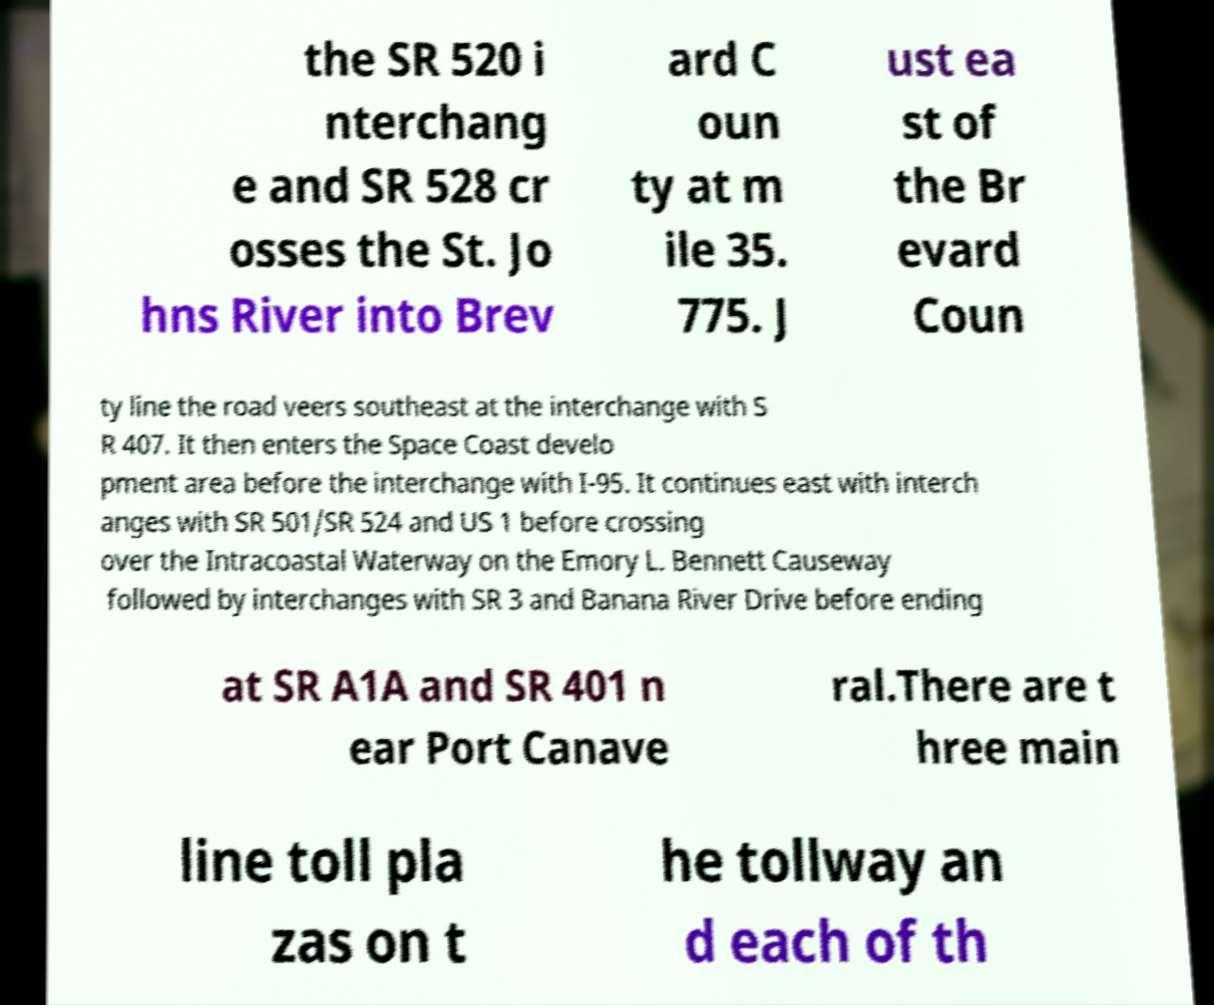Can you read and provide the text displayed in the image?This photo seems to have some interesting text. Can you extract and type it out for me? the SR 520 i nterchang e and SR 528 cr osses the St. Jo hns River into Brev ard C oun ty at m ile 35. 775. J ust ea st of the Br evard Coun ty line the road veers southeast at the interchange with S R 407. It then enters the Space Coast develo pment area before the interchange with I-95. It continues east with interch anges with SR 501/SR 524 and US 1 before crossing over the Intracoastal Waterway on the Emory L. Bennett Causeway followed by interchanges with SR 3 and Banana River Drive before ending at SR A1A and SR 401 n ear Port Canave ral.There are t hree main line toll pla zas on t he tollway an d each of th 